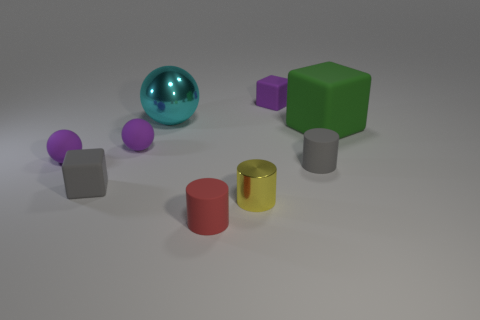Subtract all rubber cylinders. How many cylinders are left? 1 Add 1 red rubber cubes. How many objects exist? 10 Subtract all cylinders. How many objects are left? 6 Add 3 gray things. How many gray things are left? 5 Add 4 blocks. How many blocks exist? 7 Subtract 0 red blocks. How many objects are left? 9 Subtract all tiny purple rubber spheres. Subtract all tiny yellow cylinders. How many objects are left? 6 